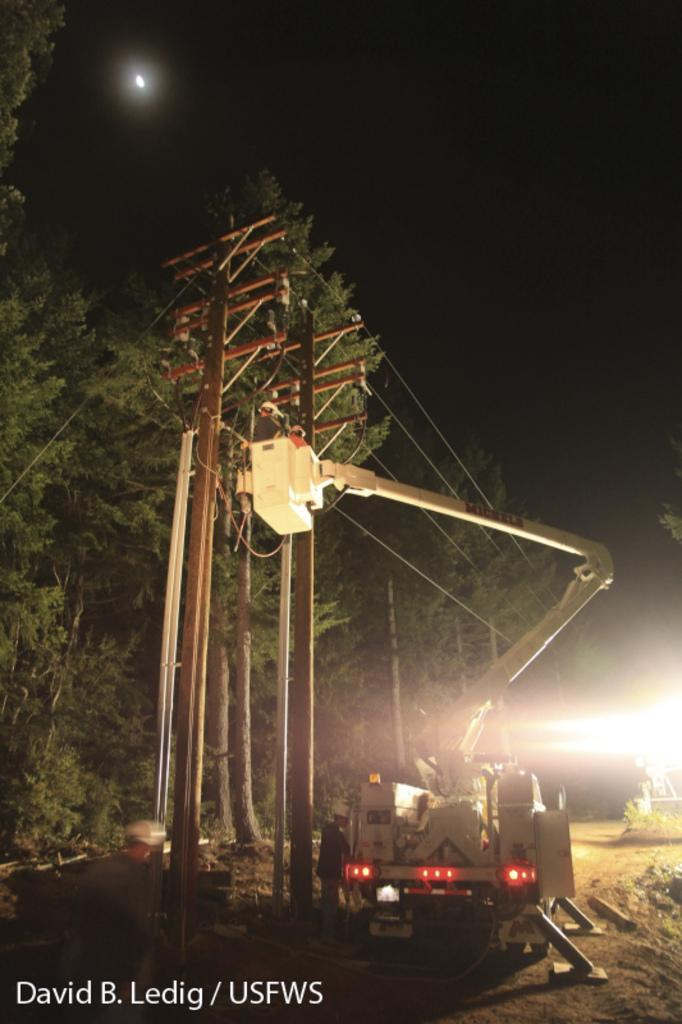What is attached to the pole in the image? There are cables attached to the pole in the image. What type of vehicle can be seen in the image? There is a vehicle in the image. What type of natural vegetation is present in the image? There are trees in the image. What is visible in the sky in the image? The sky is visible in the image, and the moon is present. Where is the flock of birds gathering in the image? There is no flock of birds present in the image. What type of club can be seen in the image? There is no club present in the image. 